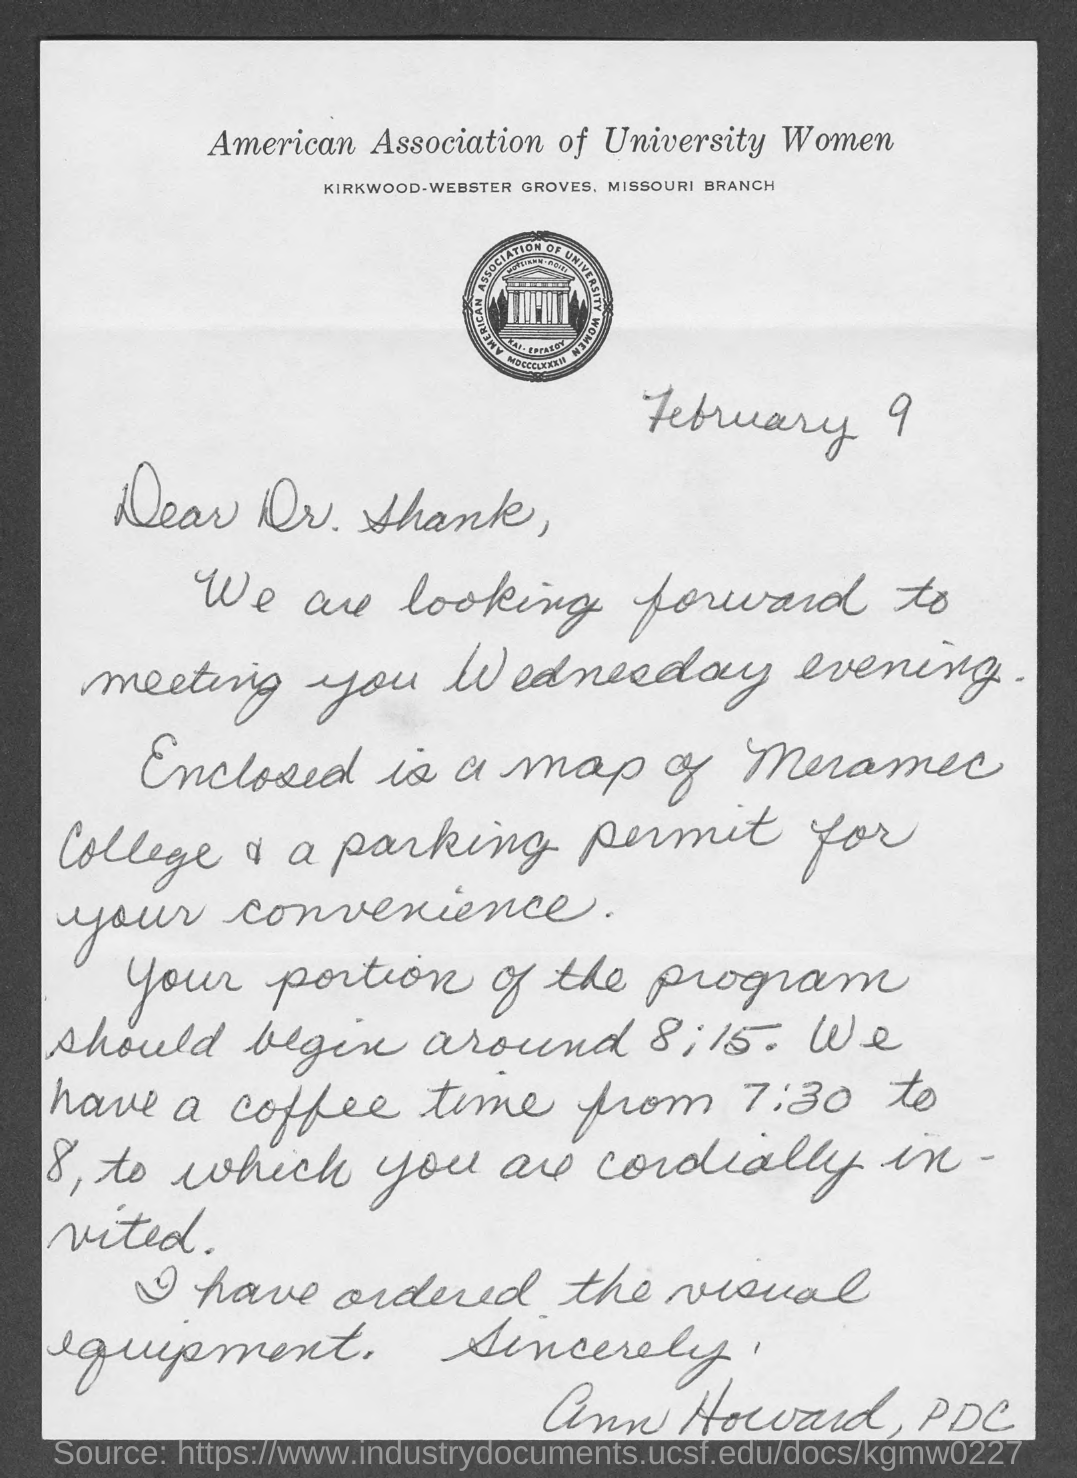What is the name of the association mentioned in the given page ?
Offer a terse response. American Association of University Women. What is the date mentioned in the given letter ?
Make the answer very short. February 9. 